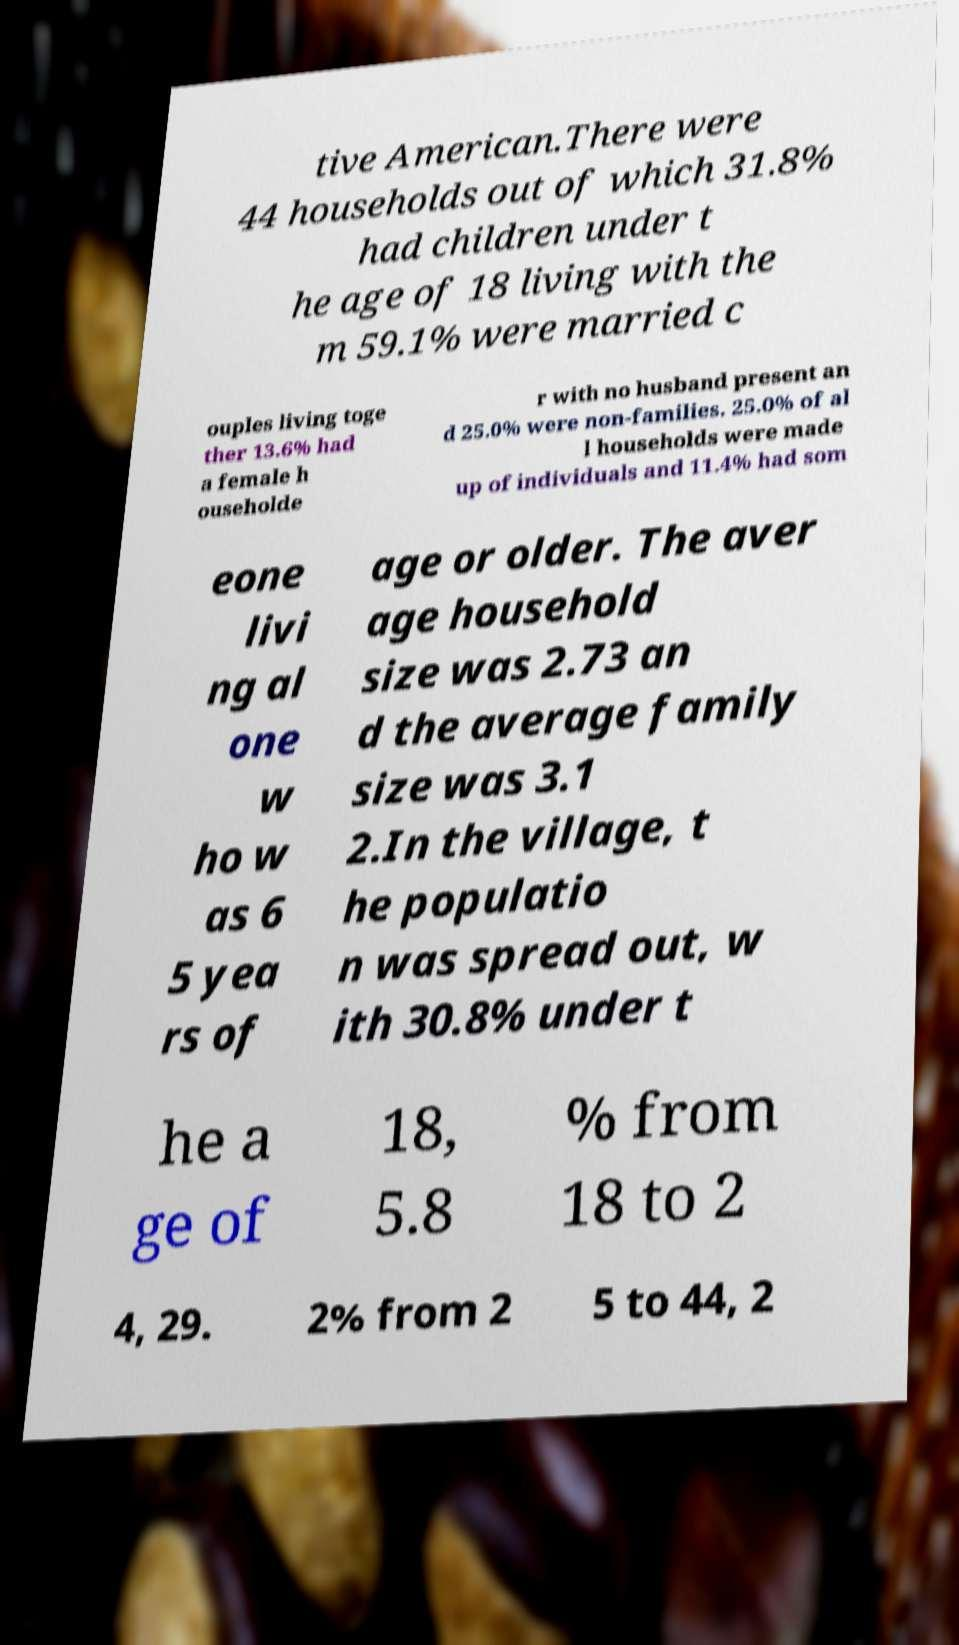Please read and relay the text visible in this image. What does it say? tive American.There were 44 households out of which 31.8% had children under t he age of 18 living with the m 59.1% were married c ouples living toge ther 13.6% had a female h ouseholde r with no husband present an d 25.0% were non-families. 25.0% of al l households were made up of individuals and 11.4% had som eone livi ng al one w ho w as 6 5 yea rs of age or older. The aver age household size was 2.73 an d the average family size was 3.1 2.In the village, t he populatio n was spread out, w ith 30.8% under t he a ge of 18, 5.8 % from 18 to 2 4, 29. 2% from 2 5 to 44, 2 